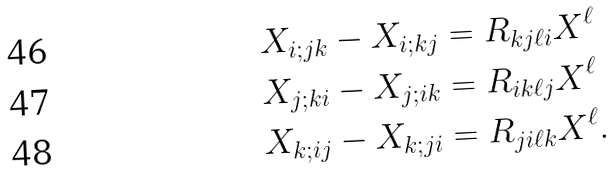<formula> <loc_0><loc_0><loc_500><loc_500>X _ { i ; j k } - X _ { i ; k j } & = R _ { k j \ell i } X ^ { \ell } \\ X _ { j ; k i } - X _ { j ; i k } & = R _ { i k \ell j } X ^ { \ell } \\ X _ { k ; i j } - X _ { k ; j i } & = R _ { j i \ell k } X ^ { \ell } .</formula> 